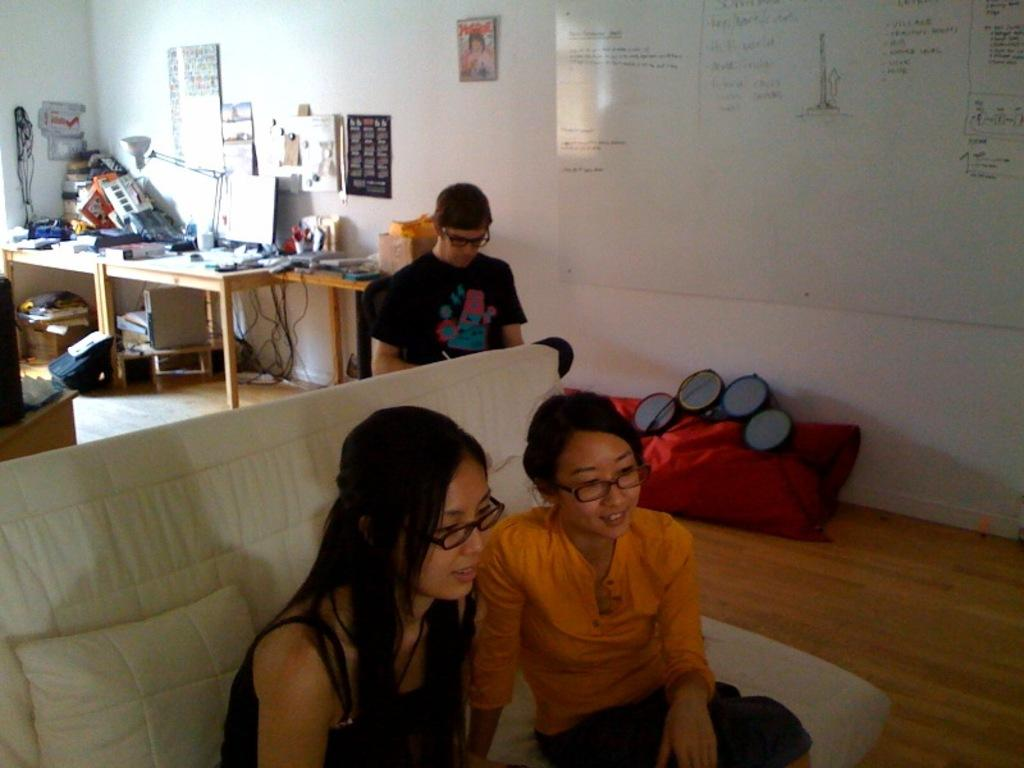How many people are sitting on a sofa in the image? There are two people sitting on a sofa in the image. What is the man in the image doing? The man is sitting on a chair in the image. What can be found on the floor in the image? There are some things on the floor in the image. What is on the desk in the image? There are some things on a desk in the image. How does the dock look like in the image? There is no dock present in the image. What is the reason for the person on the sofa to cry in the image? There is no indication of anyone crying in the image. 